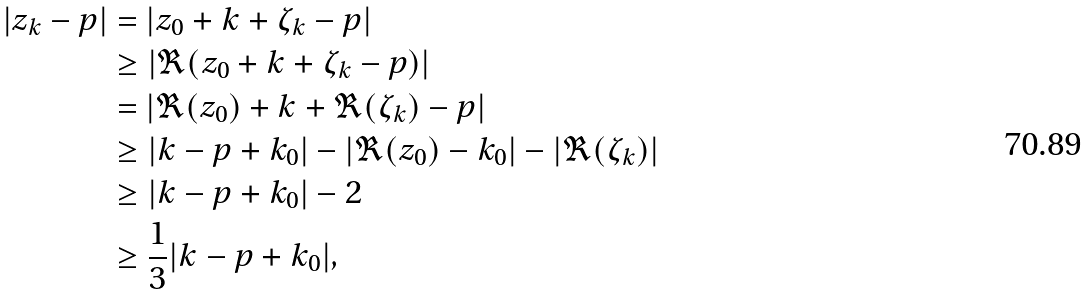<formula> <loc_0><loc_0><loc_500><loc_500>| z _ { k } - p | & = | z _ { 0 } + k + \zeta _ { k } - p | \\ & \geq | \Re ( z _ { 0 } + k + \zeta _ { k } - p ) | \\ & = | \Re ( z _ { 0 } ) + k + \Re ( \zeta _ { k } ) - p | \\ & \geq | k - p + k _ { 0 } | - | \Re ( z _ { 0 } ) - k _ { 0 } | - | \Re ( \zeta _ { k } ) | \\ & \geq | k - p + k _ { 0 } | - 2 \\ & \geq \frac { 1 } { 3 } | k - p + k _ { 0 } | ,</formula> 